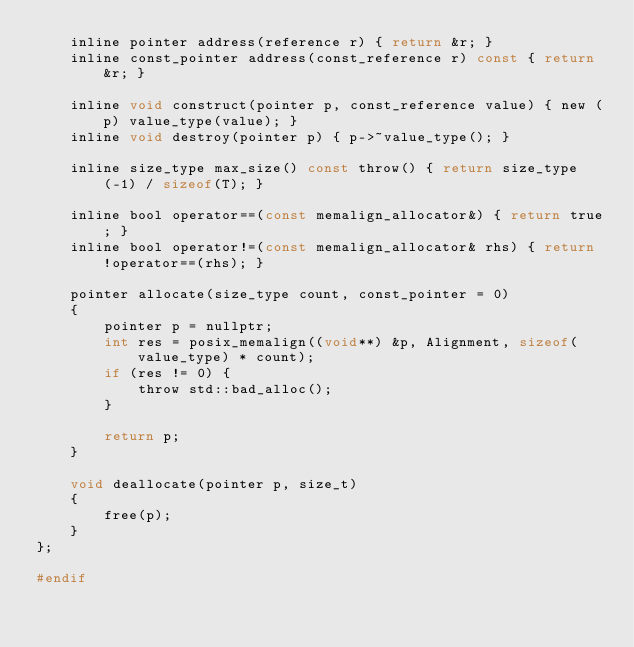<code> <loc_0><loc_0><loc_500><loc_500><_C_>    inline pointer address(reference r) { return &r; }
    inline const_pointer address(const_reference r) const { return &r; }

    inline void construct(pointer p, const_reference value) { new (p) value_type(value); }
    inline void destroy(pointer p) { p->~value_type(); }

    inline size_type max_size() const throw() { return size_type(-1) / sizeof(T); }

    inline bool operator==(const memalign_allocator&) { return true; }
    inline bool operator!=(const memalign_allocator& rhs) { return !operator==(rhs); }

    pointer allocate(size_type count, const_pointer = 0)
    {
        pointer p = nullptr;
        int res = posix_memalign((void**) &p, Alignment, sizeof(value_type) * count);
        if (res != 0) {
            throw std::bad_alloc();
        }

        return p;
    }

    void deallocate(pointer p, size_t)
    {
        free(p);
    }
};

#endif
</code> 